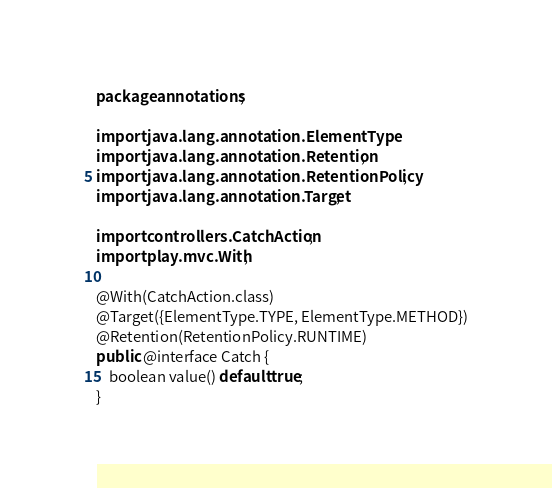Convert code to text. <code><loc_0><loc_0><loc_500><loc_500><_Java_>package annotations;

import java.lang.annotation.ElementType;
import java.lang.annotation.Retention;
import java.lang.annotation.RetentionPolicy;
import java.lang.annotation.Target;

import controllers.CatchAction;
import play.mvc.With;

@With(CatchAction.class)
@Target({ElementType.TYPE, ElementType.METHOD})
@Retention(RetentionPolicy.RUNTIME)
public @interface Catch {
	boolean value() default true;
}
</code> 